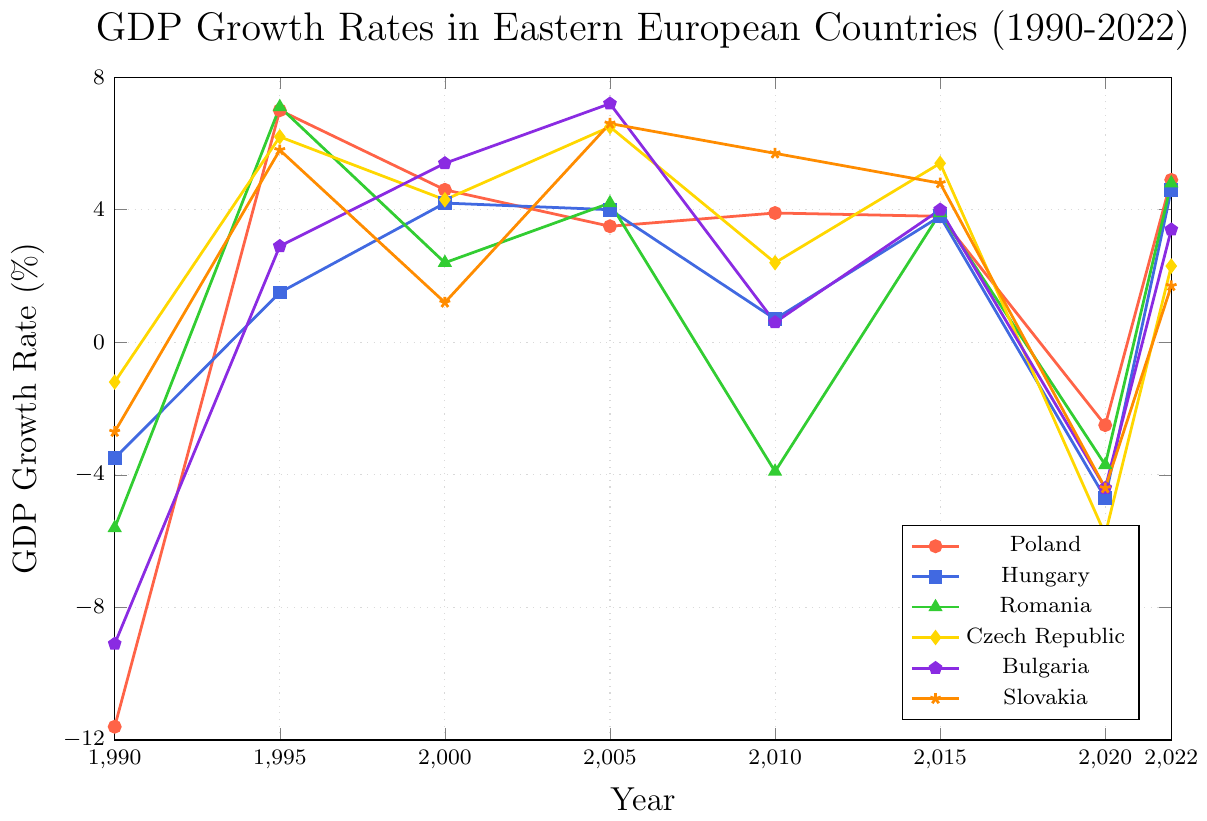Which country had the highest GDP growth rate in 1995? Check the data points for each country in 1995. Poland had 7.0%, Hungary had 1.5%, Romania had 7.1%, Czech Republic had 6.2%, Bulgaria had 2.9%, and Slovakia had 5.8%. Romania had the highest value.
Answer: Romania Which two countries had negative GDP growth rates in both 1990 and 2020? Identify the GDP growth rates for all countries in 1990 and 2020. Poland (-11.6, -2.5), Hungary (-3.5, -4.7), Romania (-5.6, -3.7), Czech Republic (-1.2, -5.8), Bulgaria (-9.1, -4.4), Slovakia (-2.7, -4.4). All six countries had negative growth rates for both years.
Answer: Poland, Hungary, Romania, Czech Republic, Bulgaria, Slovakia What was the average GDP growth rate for Slovakia between 1995 and 2022? Sum Slovakia's GDP growth rates for the years 1995, 2000, 2005, 2010, 2015, and 2022: 5.8 + 1.2 + 6.6 + 5.7 + 4.8 + 1.7 = 25.8. There are six data points, so the average is 25.8 / 6 = 4.3.
Answer: 4.3 Did any country have positive GDP growth rates after experiencing negative growth in 2020? Compare the 2020 GDP growth rates with 2022 GDP growth rates for all countries. Poland (-2.5, 4.9), Hungary (-4.7, 4.6), Romania (-3.7, 4.8), Czech Republic (-5.8, 2.3), Bulgaria (-4.4, 3.4), Slovakia (-4.4, 1.7). All countries had positive growth in 2022 after negative growth in 2020.
Answer: Yes In which year did Hungary have the lowest GDP growth rate? Review Hungary's GDP growth rates: 1990 (-3.5), 1995 (1.5), 2000 (4.2), 2005 (4.0), 2010 (0.7), 2015 (3.8), 2020 (-4.7), 2022 (4.6). The lowest rate was -4.7 in 2020.
Answer: 2020 How did the GDP growth rate of Czech Republic change from 2005 to 2010? Compare the GDP growth rates in 2005 (6.5) and 2010 (2.4) for Czech Republic. The change is 2.4 - 6.5 = -4.1, indicating a decrease of 4.1%.
Answer: Decreased by 4.1% Which country had the most stable GDP growth rate from 1995 to 2015? Calculate the range (difference between max and min values) for each country from 1995 to 2015. Poland (7.0 - 3.8 = 3.2), Hungary (4.2 - 1.5 = 2.7), Romania (7.1 - 2.4 = 4.7), Czech Republic (6.5 - 2.4 = 4.1), Bulgaria (7.2 - 2.9 = 4.3), Slovakia (6.6 - 1.2 = 5.4). Hungary has the smallest range, indicating the most stability.
Answer: Hungary 